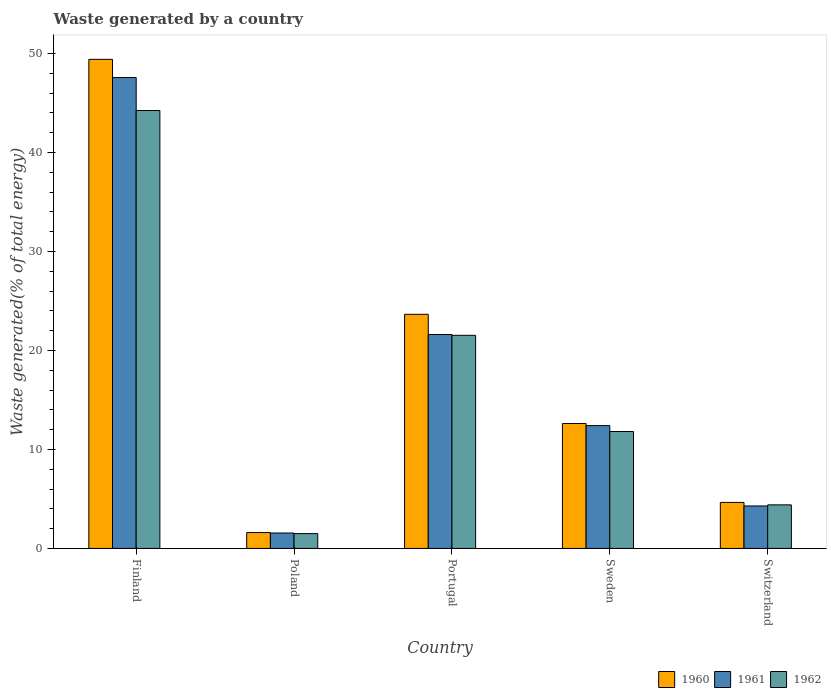How many different coloured bars are there?
Give a very brief answer. 3. Are the number of bars per tick equal to the number of legend labels?
Offer a very short reply. Yes. Are the number of bars on each tick of the X-axis equal?
Give a very brief answer. Yes. How many bars are there on the 5th tick from the left?
Your answer should be very brief. 3. How many bars are there on the 1st tick from the right?
Offer a terse response. 3. What is the label of the 1st group of bars from the left?
Ensure brevity in your answer.  Finland. What is the total waste generated in 1961 in Switzerland?
Provide a short and direct response. 4.29. Across all countries, what is the maximum total waste generated in 1960?
Ensure brevity in your answer.  49.42. Across all countries, what is the minimum total waste generated in 1961?
Offer a terse response. 1.56. In which country was the total waste generated in 1961 maximum?
Your response must be concise. Finland. In which country was the total waste generated in 1961 minimum?
Provide a short and direct response. Poland. What is the total total waste generated in 1960 in the graph?
Give a very brief answer. 91.96. What is the difference between the total waste generated in 1961 in Portugal and that in Switzerland?
Give a very brief answer. 17.32. What is the difference between the total waste generated in 1960 in Switzerland and the total waste generated in 1962 in Sweden?
Offer a very short reply. -7.17. What is the average total waste generated in 1960 per country?
Your answer should be compact. 18.39. What is the difference between the total waste generated of/in 1962 and total waste generated of/in 1960 in Poland?
Ensure brevity in your answer.  -0.11. What is the ratio of the total waste generated in 1961 in Finland to that in Sweden?
Your response must be concise. 3.83. Is the total waste generated in 1962 in Sweden less than that in Switzerland?
Give a very brief answer. No. What is the difference between the highest and the second highest total waste generated in 1960?
Make the answer very short. 36.8. What is the difference between the highest and the lowest total waste generated in 1962?
Offer a very short reply. 42.75. In how many countries, is the total waste generated in 1962 greater than the average total waste generated in 1962 taken over all countries?
Your answer should be very brief. 2. Is the sum of the total waste generated in 1962 in Finland and Poland greater than the maximum total waste generated in 1961 across all countries?
Provide a short and direct response. No. How many countries are there in the graph?
Offer a terse response. 5. Does the graph contain any zero values?
Your answer should be compact. No. Where does the legend appear in the graph?
Your answer should be very brief. Bottom right. How many legend labels are there?
Make the answer very short. 3. What is the title of the graph?
Offer a very short reply. Waste generated by a country. What is the label or title of the X-axis?
Make the answer very short. Country. What is the label or title of the Y-axis?
Your answer should be compact. Waste generated(% of total energy). What is the Waste generated(% of total energy) in 1960 in Finland?
Provide a short and direct response. 49.42. What is the Waste generated(% of total energy) of 1961 in Finland?
Ensure brevity in your answer.  47.58. What is the Waste generated(% of total energy) in 1962 in Finland?
Your answer should be compact. 44.25. What is the Waste generated(% of total energy) in 1960 in Poland?
Your answer should be very brief. 1.6. What is the Waste generated(% of total energy) in 1961 in Poland?
Your answer should be very brief. 1.56. What is the Waste generated(% of total energy) in 1962 in Poland?
Your answer should be very brief. 1.5. What is the Waste generated(% of total energy) of 1960 in Portugal?
Provide a succinct answer. 23.66. What is the Waste generated(% of total energy) of 1961 in Portugal?
Keep it short and to the point. 21.62. What is the Waste generated(% of total energy) of 1962 in Portugal?
Provide a succinct answer. 21.53. What is the Waste generated(% of total energy) in 1960 in Sweden?
Provide a short and direct response. 12.62. What is the Waste generated(% of total energy) of 1961 in Sweden?
Your answer should be very brief. 12.41. What is the Waste generated(% of total energy) of 1962 in Sweden?
Offer a very short reply. 11.82. What is the Waste generated(% of total energy) of 1960 in Switzerland?
Ensure brevity in your answer.  4.65. What is the Waste generated(% of total energy) in 1961 in Switzerland?
Your response must be concise. 4.29. What is the Waste generated(% of total energy) of 1962 in Switzerland?
Ensure brevity in your answer.  4.4. Across all countries, what is the maximum Waste generated(% of total energy) in 1960?
Give a very brief answer. 49.42. Across all countries, what is the maximum Waste generated(% of total energy) in 1961?
Provide a succinct answer. 47.58. Across all countries, what is the maximum Waste generated(% of total energy) of 1962?
Provide a succinct answer. 44.25. Across all countries, what is the minimum Waste generated(% of total energy) in 1960?
Provide a short and direct response. 1.6. Across all countries, what is the minimum Waste generated(% of total energy) in 1961?
Give a very brief answer. 1.56. Across all countries, what is the minimum Waste generated(% of total energy) in 1962?
Provide a succinct answer. 1.5. What is the total Waste generated(% of total energy) in 1960 in the graph?
Your answer should be compact. 91.96. What is the total Waste generated(% of total energy) of 1961 in the graph?
Your response must be concise. 87.46. What is the total Waste generated(% of total energy) in 1962 in the graph?
Offer a very short reply. 83.5. What is the difference between the Waste generated(% of total energy) of 1960 in Finland and that in Poland?
Provide a short and direct response. 47.82. What is the difference between the Waste generated(% of total energy) in 1961 in Finland and that in Poland?
Provide a succinct answer. 46.02. What is the difference between the Waste generated(% of total energy) of 1962 in Finland and that in Poland?
Your response must be concise. 42.75. What is the difference between the Waste generated(% of total energy) of 1960 in Finland and that in Portugal?
Your answer should be very brief. 25.77. What is the difference between the Waste generated(% of total energy) in 1961 in Finland and that in Portugal?
Your response must be concise. 25.96. What is the difference between the Waste generated(% of total energy) of 1962 in Finland and that in Portugal?
Provide a short and direct response. 22.72. What is the difference between the Waste generated(% of total energy) in 1960 in Finland and that in Sweden?
Your answer should be very brief. 36.8. What is the difference between the Waste generated(% of total energy) of 1961 in Finland and that in Sweden?
Your answer should be very brief. 35.17. What is the difference between the Waste generated(% of total energy) in 1962 in Finland and that in Sweden?
Make the answer very short. 32.44. What is the difference between the Waste generated(% of total energy) of 1960 in Finland and that in Switzerland?
Keep it short and to the point. 44.77. What is the difference between the Waste generated(% of total energy) in 1961 in Finland and that in Switzerland?
Provide a succinct answer. 43.29. What is the difference between the Waste generated(% of total energy) of 1962 in Finland and that in Switzerland?
Offer a terse response. 39.85. What is the difference between the Waste generated(% of total energy) of 1960 in Poland and that in Portugal?
Provide a succinct answer. -22.05. What is the difference between the Waste generated(% of total energy) of 1961 in Poland and that in Portugal?
Give a very brief answer. -20.06. What is the difference between the Waste generated(% of total energy) of 1962 in Poland and that in Portugal?
Your response must be concise. -20.03. What is the difference between the Waste generated(% of total energy) in 1960 in Poland and that in Sweden?
Give a very brief answer. -11.02. What is the difference between the Waste generated(% of total energy) in 1961 in Poland and that in Sweden?
Keep it short and to the point. -10.85. What is the difference between the Waste generated(% of total energy) of 1962 in Poland and that in Sweden?
Offer a very short reply. -10.32. What is the difference between the Waste generated(% of total energy) of 1960 in Poland and that in Switzerland?
Provide a succinct answer. -3.04. What is the difference between the Waste generated(% of total energy) of 1961 in Poland and that in Switzerland?
Keep it short and to the point. -2.73. What is the difference between the Waste generated(% of total energy) in 1962 in Poland and that in Switzerland?
Your answer should be compact. -2.9. What is the difference between the Waste generated(% of total energy) of 1960 in Portugal and that in Sweden?
Keep it short and to the point. 11.03. What is the difference between the Waste generated(% of total energy) of 1961 in Portugal and that in Sweden?
Your response must be concise. 9.2. What is the difference between the Waste generated(% of total energy) in 1962 in Portugal and that in Sweden?
Your answer should be very brief. 9.72. What is the difference between the Waste generated(% of total energy) of 1960 in Portugal and that in Switzerland?
Provide a short and direct response. 19.01. What is the difference between the Waste generated(% of total energy) of 1961 in Portugal and that in Switzerland?
Your answer should be very brief. 17.32. What is the difference between the Waste generated(% of total energy) in 1962 in Portugal and that in Switzerland?
Provide a short and direct response. 17.13. What is the difference between the Waste generated(% of total energy) of 1960 in Sweden and that in Switzerland?
Provide a succinct answer. 7.97. What is the difference between the Waste generated(% of total energy) in 1961 in Sweden and that in Switzerland?
Your answer should be compact. 8.12. What is the difference between the Waste generated(% of total energy) in 1962 in Sweden and that in Switzerland?
Give a very brief answer. 7.41. What is the difference between the Waste generated(% of total energy) of 1960 in Finland and the Waste generated(% of total energy) of 1961 in Poland?
Provide a succinct answer. 47.86. What is the difference between the Waste generated(% of total energy) of 1960 in Finland and the Waste generated(% of total energy) of 1962 in Poland?
Give a very brief answer. 47.92. What is the difference between the Waste generated(% of total energy) in 1961 in Finland and the Waste generated(% of total energy) in 1962 in Poland?
Offer a very short reply. 46.08. What is the difference between the Waste generated(% of total energy) in 1960 in Finland and the Waste generated(% of total energy) in 1961 in Portugal?
Provide a succinct answer. 27.81. What is the difference between the Waste generated(% of total energy) of 1960 in Finland and the Waste generated(% of total energy) of 1962 in Portugal?
Keep it short and to the point. 27.89. What is the difference between the Waste generated(% of total energy) in 1961 in Finland and the Waste generated(% of total energy) in 1962 in Portugal?
Make the answer very short. 26.05. What is the difference between the Waste generated(% of total energy) in 1960 in Finland and the Waste generated(% of total energy) in 1961 in Sweden?
Your answer should be very brief. 37.01. What is the difference between the Waste generated(% of total energy) in 1960 in Finland and the Waste generated(% of total energy) in 1962 in Sweden?
Make the answer very short. 37.61. What is the difference between the Waste generated(% of total energy) of 1961 in Finland and the Waste generated(% of total energy) of 1962 in Sweden?
Give a very brief answer. 35.77. What is the difference between the Waste generated(% of total energy) of 1960 in Finland and the Waste generated(% of total energy) of 1961 in Switzerland?
Ensure brevity in your answer.  45.13. What is the difference between the Waste generated(% of total energy) in 1960 in Finland and the Waste generated(% of total energy) in 1962 in Switzerland?
Provide a succinct answer. 45.02. What is the difference between the Waste generated(% of total energy) of 1961 in Finland and the Waste generated(% of total energy) of 1962 in Switzerland?
Make the answer very short. 43.18. What is the difference between the Waste generated(% of total energy) of 1960 in Poland and the Waste generated(% of total energy) of 1961 in Portugal?
Ensure brevity in your answer.  -20.01. What is the difference between the Waste generated(% of total energy) of 1960 in Poland and the Waste generated(% of total energy) of 1962 in Portugal?
Your answer should be very brief. -19.93. What is the difference between the Waste generated(% of total energy) of 1961 in Poland and the Waste generated(% of total energy) of 1962 in Portugal?
Make the answer very short. -19.98. What is the difference between the Waste generated(% of total energy) of 1960 in Poland and the Waste generated(% of total energy) of 1961 in Sweden?
Keep it short and to the point. -10.81. What is the difference between the Waste generated(% of total energy) of 1960 in Poland and the Waste generated(% of total energy) of 1962 in Sweden?
Provide a short and direct response. -10.21. What is the difference between the Waste generated(% of total energy) in 1961 in Poland and the Waste generated(% of total energy) in 1962 in Sweden?
Keep it short and to the point. -10.26. What is the difference between the Waste generated(% of total energy) in 1960 in Poland and the Waste generated(% of total energy) in 1961 in Switzerland?
Your response must be concise. -2.69. What is the difference between the Waste generated(% of total energy) of 1960 in Poland and the Waste generated(% of total energy) of 1962 in Switzerland?
Provide a short and direct response. -2.8. What is the difference between the Waste generated(% of total energy) in 1961 in Poland and the Waste generated(% of total energy) in 1962 in Switzerland?
Offer a terse response. -2.84. What is the difference between the Waste generated(% of total energy) of 1960 in Portugal and the Waste generated(% of total energy) of 1961 in Sweden?
Ensure brevity in your answer.  11.24. What is the difference between the Waste generated(% of total energy) in 1960 in Portugal and the Waste generated(% of total energy) in 1962 in Sweden?
Give a very brief answer. 11.84. What is the difference between the Waste generated(% of total energy) of 1961 in Portugal and the Waste generated(% of total energy) of 1962 in Sweden?
Offer a terse response. 9.8. What is the difference between the Waste generated(% of total energy) in 1960 in Portugal and the Waste generated(% of total energy) in 1961 in Switzerland?
Make the answer very short. 19.36. What is the difference between the Waste generated(% of total energy) of 1960 in Portugal and the Waste generated(% of total energy) of 1962 in Switzerland?
Give a very brief answer. 19.25. What is the difference between the Waste generated(% of total energy) of 1961 in Portugal and the Waste generated(% of total energy) of 1962 in Switzerland?
Offer a very short reply. 17.21. What is the difference between the Waste generated(% of total energy) of 1960 in Sweden and the Waste generated(% of total energy) of 1961 in Switzerland?
Keep it short and to the point. 8.33. What is the difference between the Waste generated(% of total energy) of 1960 in Sweden and the Waste generated(% of total energy) of 1962 in Switzerland?
Ensure brevity in your answer.  8.22. What is the difference between the Waste generated(% of total energy) in 1961 in Sweden and the Waste generated(% of total energy) in 1962 in Switzerland?
Ensure brevity in your answer.  8.01. What is the average Waste generated(% of total energy) of 1960 per country?
Give a very brief answer. 18.39. What is the average Waste generated(% of total energy) in 1961 per country?
Provide a short and direct response. 17.49. What is the average Waste generated(% of total energy) in 1962 per country?
Provide a succinct answer. 16.7. What is the difference between the Waste generated(% of total energy) of 1960 and Waste generated(% of total energy) of 1961 in Finland?
Your answer should be very brief. 1.84. What is the difference between the Waste generated(% of total energy) of 1960 and Waste generated(% of total energy) of 1962 in Finland?
Keep it short and to the point. 5.17. What is the difference between the Waste generated(% of total energy) in 1961 and Waste generated(% of total energy) in 1962 in Finland?
Give a very brief answer. 3.33. What is the difference between the Waste generated(% of total energy) in 1960 and Waste generated(% of total energy) in 1961 in Poland?
Your answer should be very brief. 0.05. What is the difference between the Waste generated(% of total energy) of 1960 and Waste generated(% of total energy) of 1962 in Poland?
Keep it short and to the point. 0.11. What is the difference between the Waste generated(% of total energy) in 1961 and Waste generated(% of total energy) in 1962 in Poland?
Ensure brevity in your answer.  0.06. What is the difference between the Waste generated(% of total energy) in 1960 and Waste generated(% of total energy) in 1961 in Portugal?
Your response must be concise. 2.04. What is the difference between the Waste generated(% of total energy) of 1960 and Waste generated(% of total energy) of 1962 in Portugal?
Keep it short and to the point. 2.12. What is the difference between the Waste generated(% of total energy) of 1961 and Waste generated(% of total energy) of 1962 in Portugal?
Ensure brevity in your answer.  0.08. What is the difference between the Waste generated(% of total energy) in 1960 and Waste generated(% of total energy) in 1961 in Sweden?
Provide a short and direct response. 0.21. What is the difference between the Waste generated(% of total energy) in 1960 and Waste generated(% of total energy) in 1962 in Sweden?
Provide a short and direct response. 0.81. What is the difference between the Waste generated(% of total energy) in 1961 and Waste generated(% of total energy) in 1962 in Sweden?
Offer a terse response. 0.6. What is the difference between the Waste generated(% of total energy) of 1960 and Waste generated(% of total energy) of 1961 in Switzerland?
Provide a short and direct response. 0.36. What is the difference between the Waste generated(% of total energy) in 1960 and Waste generated(% of total energy) in 1962 in Switzerland?
Offer a very short reply. 0.25. What is the difference between the Waste generated(% of total energy) in 1961 and Waste generated(% of total energy) in 1962 in Switzerland?
Keep it short and to the point. -0.11. What is the ratio of the Waste generated(% of total energy) in 1960 in Finland to that in Poland?
Your answer should be compact. 30.8. What is the ratio of the Waste generated(% of total energy) of 1961 in Finland to that in Poland?
Your response must be concise. 30.53. What is the ratio of the Waste generated(% of total energy) of 1962 in Finland to that in Poland?
Provide a succinct answer. 29.52. What is the ratio of the Waste generated(% of total energy) in 1960 in Finland to that in Portugal?
Your response must be concise. 2.09. What is the ratio of the Waste generated(% of total energy) of 1961 in Finland to that in Portugal?
Provide a succinct answer. 2.2. What is the ratio of the Waste generated(% of total energy) of 1962 in Finland to that in Portugal?
Provide a short and direct response. 2.05. What is the ratio of the Waste generated(% of total energy) in 1960 in Finland to that in Sweden?
Offer a very short reply. 3.92. What is the ratio of the Waste generated(% of total energy) of 1961 in Finland to that in Sweden?
Make the answer very short. 3.83. What is the ratio of the Waste generated(% of total energy) in 1962 in Finland to that in Sweden?
Offer a terse response. 3.75. What is the ratio of the Waste generated(% of total energy) of 1960 in Finland to that in Switzerland?
Ensure brevity in your answer.  10.63. What is the ratio of the Waste generated(% of total energy) of 1961 in Finland to that in Switzerland?
Provide a short and direct response. 11.09. What is the ratio of the Waste generated(% of total energy) of 1962 in Finland to that in Switzerland?
Give a very brief answer. 10.05. What is the ratio of the Waste generated(% of total energy) of 1960 in Poland to that in Portugal?
Your answer should be very brief. 0.07. What is the ratio of the Waste generated(% of total energy) in 1961 in Poland to that in Portugal?
Provide a short and direct response. 0.07. What is the ratio of the Waste generated(% of total energy) in 1962 in Poland to that in Portugal?
Offer a very short reply. 0.07. What is the ratio of the Waste generated(% of total energy) in 1960 in Poland to that in Sweden?
Offer a terse response. 0.13. What is the ratio of the Waste generated(% of total energy) in 1961 in Poland to that in Sweden?
Ensure brevity in your answer.  0.13. What is the ratio of the Waste generated(% of total energy) in 1962 in Poland to that in Sweden?
Your answer should be very brief. 0.13. What is the ratio of the Waste generated(% of total energy) of 1960 in Poland to that in Switzerland?
Provide a succinct answer. 0.35. What is the ratio of the Waste generated(% of total energy) in 1961 in Poland to that in Switzerland?
Provide a short and direct response. 0.36. What is the ratio of the Waste generated(% of total energy) of 1962 in Poland to that in Switzerland?
Keep it short and to the point. 0.34. What is the ratio of the Waste generated(% of total energy) of 1960 in Portugal to that in Sweden?
Keep it short and to the point. 1.87. What is the ratio of the Waste generated(% of total energy) in 1961 in Portugal to that in Sweden?
Make the answer very short. 1.74. What is the ratio of the Waste generated(% of total energy) in 1962 in Portugal to that in Sweden?
Make the answer very short. 1.82. What is the ratio of the Waste generated(% of total energy) of 1960 in Portugal to that in Switzerland?
Your answer should be compact. 5.09. What is the ratio of the Waste generated(% of total energy) of 1961 in Portugal to that in Switzerland?
Ensure brevity in your answer.  5.04. What is the ratio of the Waste generated(% of total energy) in 1962 in Portugal to that in Switzerland?
Give a very brief answer. 4.89. What is the ratio of the Waste generated(% of total energy) in 1960 in Sweden to that in Switzerland?
Your response must be concise. 2.71. What is the ratio of the Waste generated(% of total energy) of 1961 in Sweden to that in Switzerland?
Your answer should be compact. 2.89. What is the ratio of the Waste generated(% of total energy) in 1962 in Sweden to that in Switzerland?
Provide a succinct answer. 2.68. What is the difference between the highest and the second highest Waste generated(% of total energy) in 1960?
Offer a very short reply. 25.77. What is the difference between the highest and the second highest Waste generated(% of total energy) of 1961?
Give a very brief answer. 25.96. What is the difference between the highest and the second highest Waste generated(% of total energy) of 1962?
Provide a short and direct response. 22.72. What is the difference between the highest and the lowest Waste generated(% of total energy) in 1960?
Provide a succinct answer. 47.82. What is the difference between the highest and the lowest Waste generated(% of total energy) of 1961?
Offer a terse response. 46.02. What is the difference between the highest and the lowest Waste generated(% of total energy) in 1962?
Give a very brief answer. 42.75. 